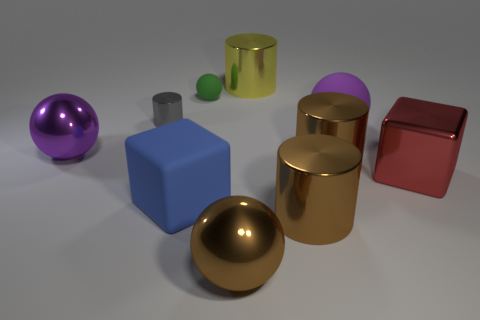Is the color of the large rubber ball the same as the metal sphere behind the large red cube?
Your answer should be very brief. Yes. What material is the red block that is the same size as the purple metal sphere?
Ensure brevity in your answer.  Metal. Are there fewer big red metal things that are behind the gray thing than large brown metallic cylinders behind the large red object?
Your answer should be compact. Yes. There is a purple thing behind the large object left of the small metal object; what is its shape?
Provide a succinct answer. Sphere. Are any tiny cyan metallic spheres visible?
Give a very brief answer. No. What color is the metallic ball that is behind the big blue rubber cube?
Ensure brevity in your answer.  Purple. Are there any purple metallic things left of the gray thing?
Your response must be concise. Yes. Are there more small purple rubber balls than tiny cylinders?
Provide a short and direct response. No. What is the color of the sphere in front of the large cube that is to the right of the metal ball in front of the blue matte thing?
Provide a short and direct response. Brown. There is a big block that is made of the same material as the green thing; what color is it?
Provide a succinct answer. Blue. 